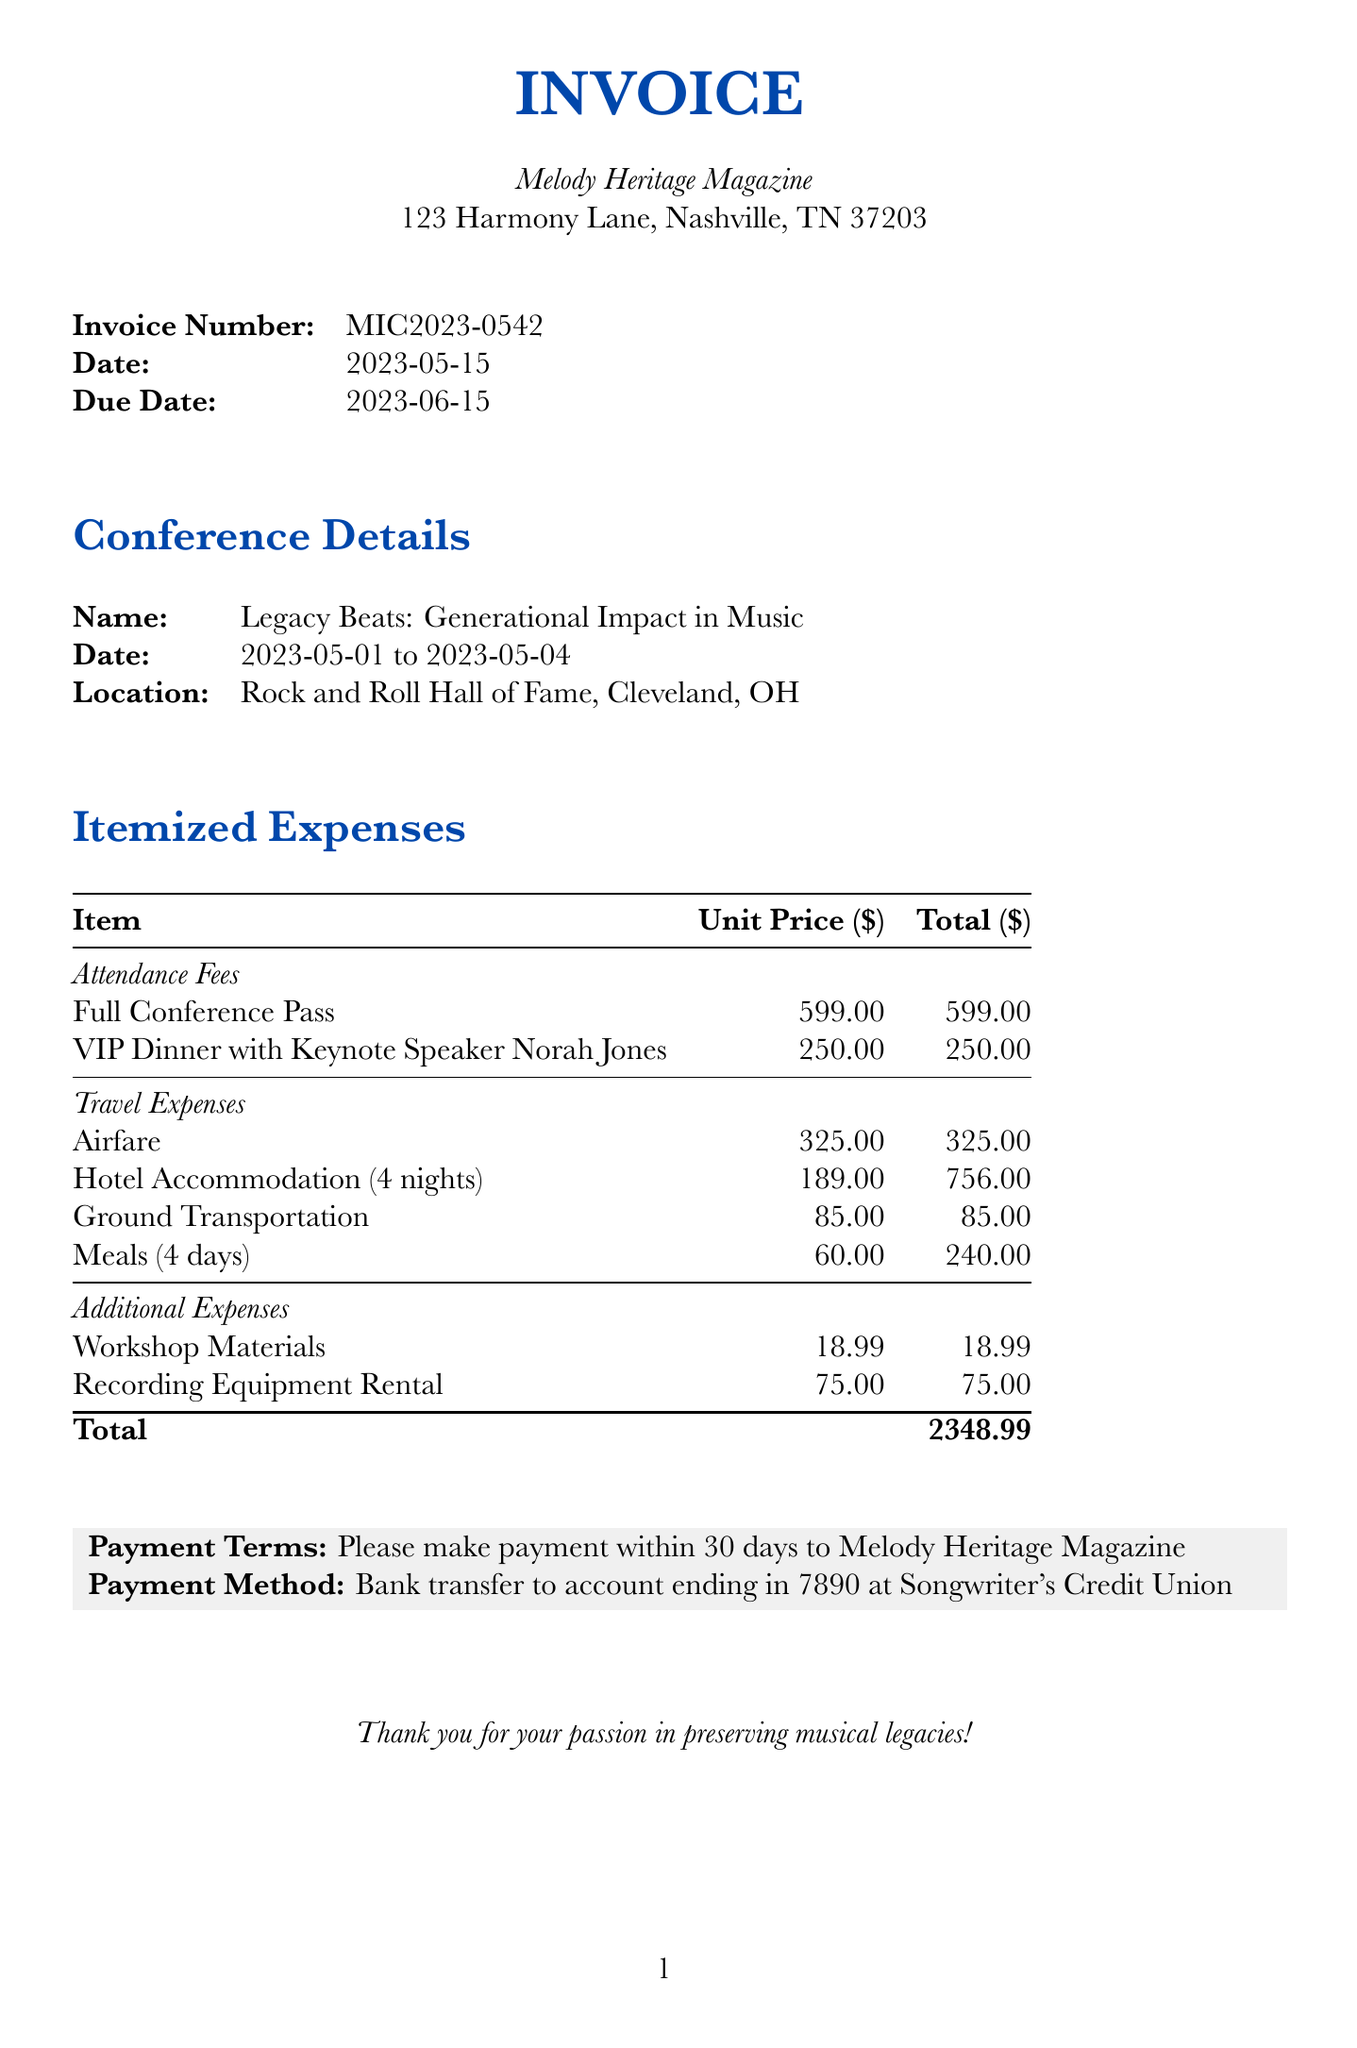What is the invoice number? The invoice number is specified in the document as a unique identifier for this transaction.
Answer: MIC2023-0542 What is the total amount due? The total amount due is listed at the end of the document after itemized expenses and represents the overall cost to be paid.
Answer: 2348.99 Who is the client for this invoice? The client name is listed at the beginning of the invoice, indicating the entity to whom the invoice is issued.
Answer: Melody Heritage Magazine What is the date of the conference? The conference date is provided in the document, indicating the specific days the event took place.
Answer: 2023-05-01 to 2023-05-04 How much was spent on airfare? The airfare is detailed in the travel expenses section, providing the cost of the flight as a specific item in the invoice.
Answer: 325.00 What type of event was the VIP dinner associated with? The description of the VIP dinner indicates that it is linked to specific discussions about legacy in music.
Answer: Exclusive dinner event discussing Norah's grandfather's influence What is the payment method specified in the invoice? The payment method outlines how the client should make the payment as mentioned in the payment terms section.
Answer: Bank transfer to account ending in 7890 at Songwriter's Credit Union How many nights was hotel accommodation for? The hotel accommodation line item specifies the duration of the stay, which is important for calculating total costs.
Answer: 4 nights What was included in the meals expense? The meals expense description notes that it is for a specific duration of the conference excluding a particular dinner event.
Answer: Per diem for 4 days (excluding VIP dinner) 